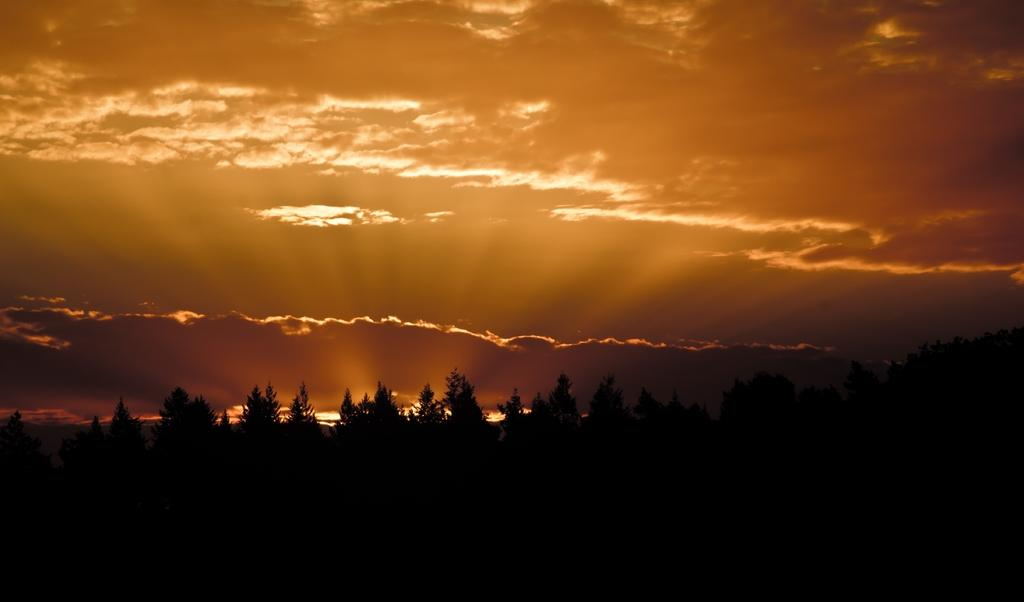What is visible at the top of the image? The sky is visible at the top of the image. What can be seen in the sky? There are clouds in the sky. What type of vegetation is present in the image? There are trees in the image. How much butter is visible on the trees in the image? There is no butter present on the trees in the image; they are covered with leaves and branches. 